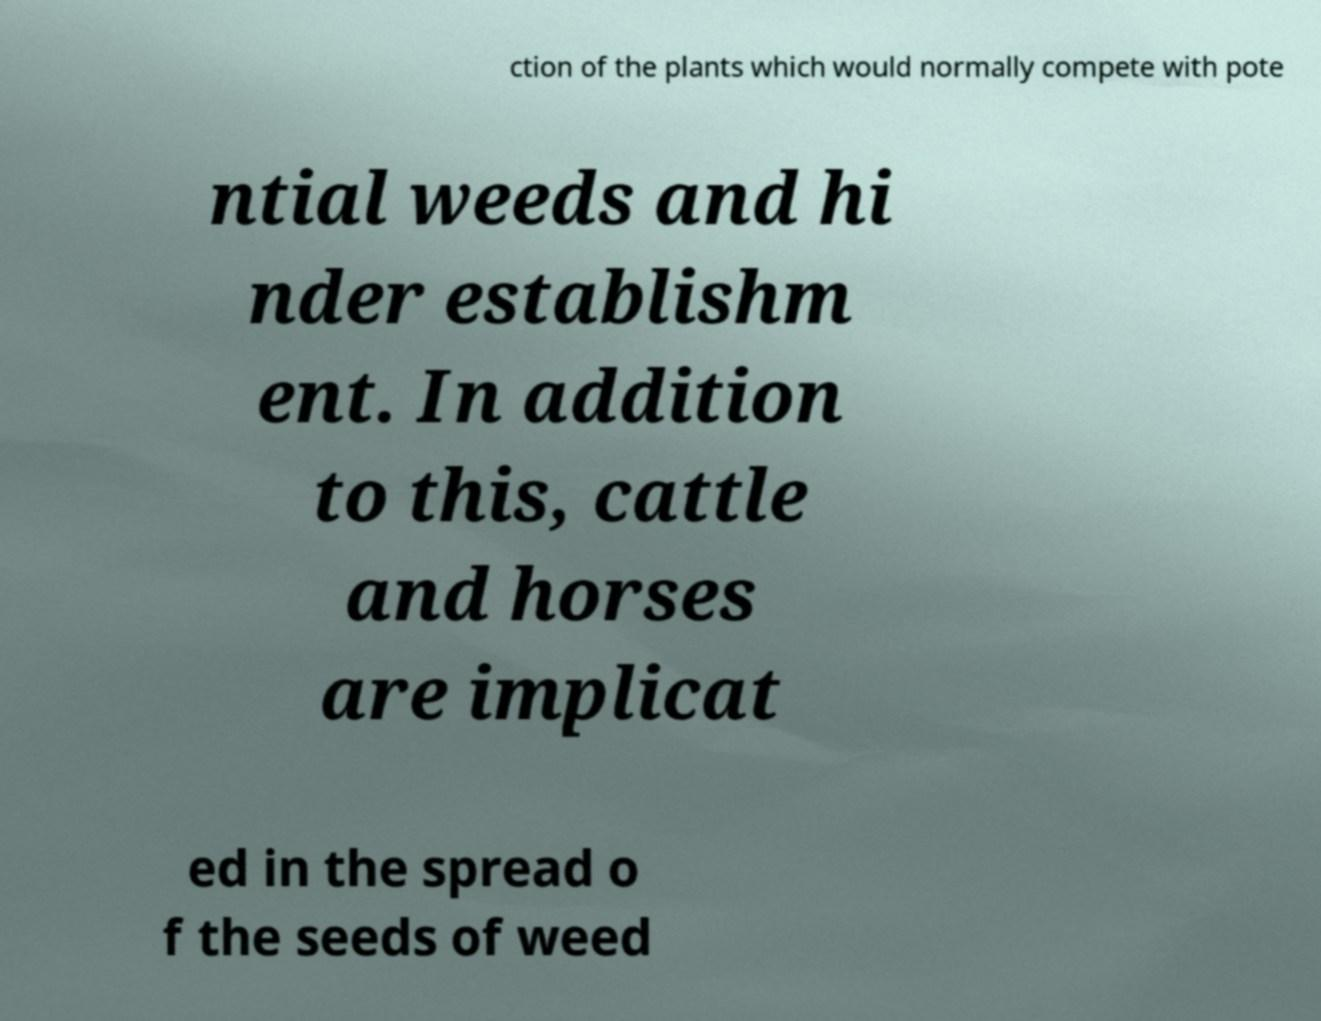Can you accurately transcribe the text from the provided image for me? ction of the plants which would normally compete with pote ntial weeds and hi nder establishm ent. In addition to this, cattle and horses are implicat ed in the spread o f the seeds of weed 